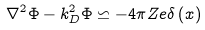Convert formula to latex. <formula><loc_0><loc_0><loc_500><loc_500>\nabla ^ { 2 } \Phi - k _ { D } ^ { 2 } \Phi \backsimeq - 4 \pi Z e \delta \left ( x \right )</formula> 